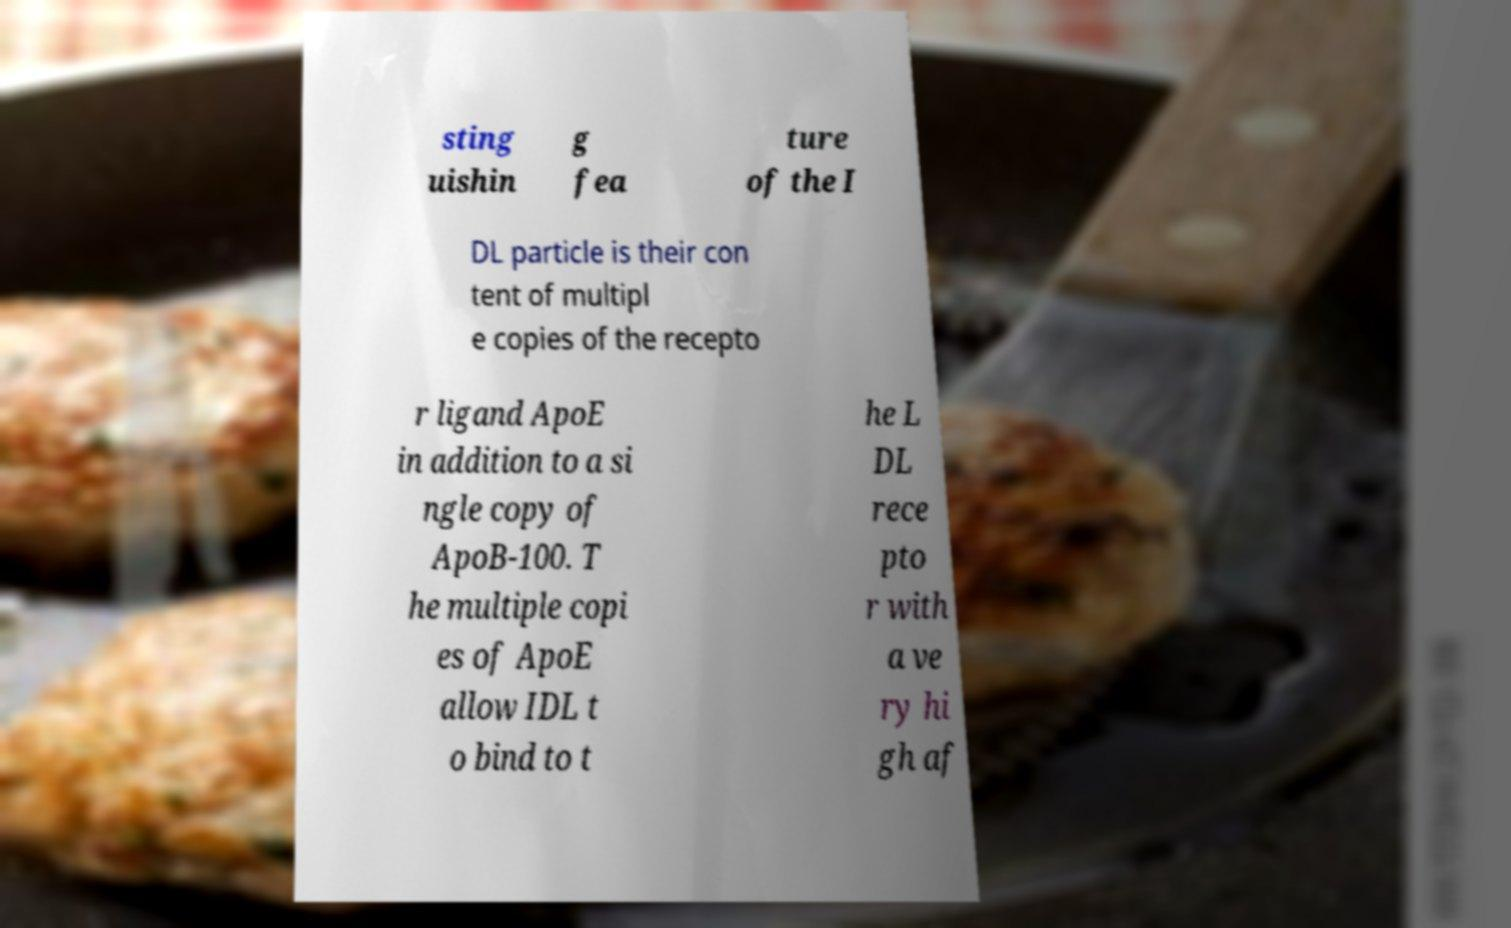I need the written content from this picture converted into text. Can you do that? sting uishin g fea ture of the I DL particle is their con tent of multipl e copies of the recepto r ligand ApoE in addition to a si ngle copy of ApoB-100. T he multiple copi es of ApoE allow IDL t o bind to t he L DL rece pto r with a ve ry hi gh af 